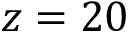<formula> <loc_0><loc_0><loc_500><loc_500>z = 2 0</formula> 